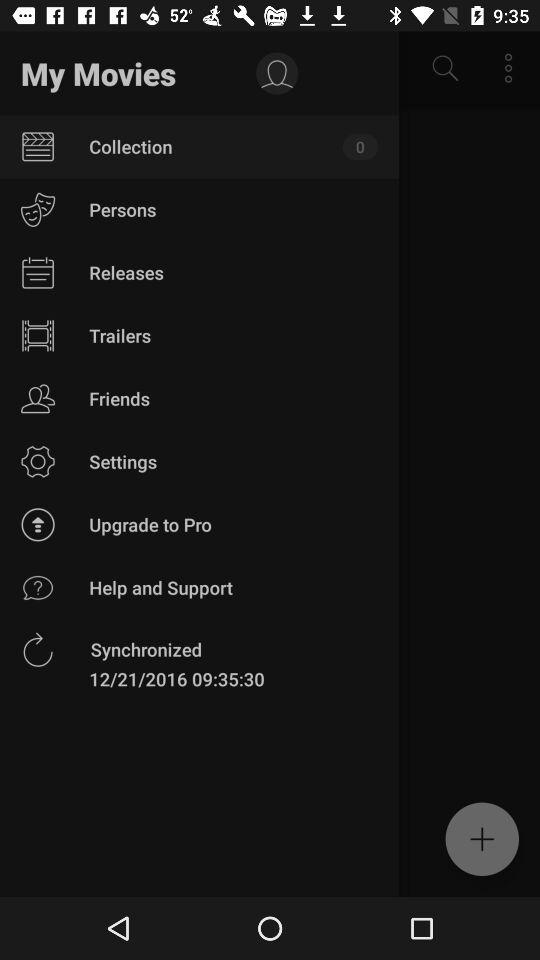What is the synchronization time? The synchronization time is 09:35:30. 